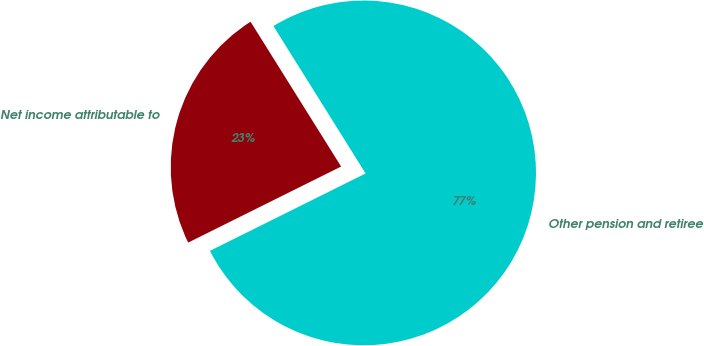Convert chart to OTSL. <chart><loc_0><loc_0><loc_500><loc_500><pie_chart><fcel>Other pension and retiree<fcel>Net income attributable to<nl><fcel>76.55%<fcel>23.45%<nl></chart> 